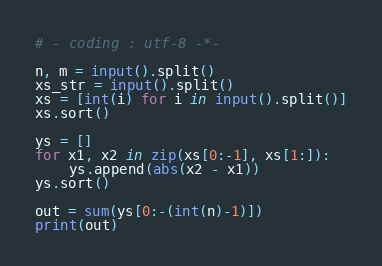<code> <loc_0><loc_0><loc_500><loc_500><_Python_># - coding : utf-8 -*-
 
n, m = input().split()
xs_str = input().split()
xs = [int(i) for i in input().split()]
xs.sort()
 
ys = []
for x1, x2 in zip(xs[0:-1], xs[1:]):
    ys.append(abs(x2 - x1))
ys.sort()
 
out = sum(ys[0:-(int(n)-1)])
print(out)</code> 